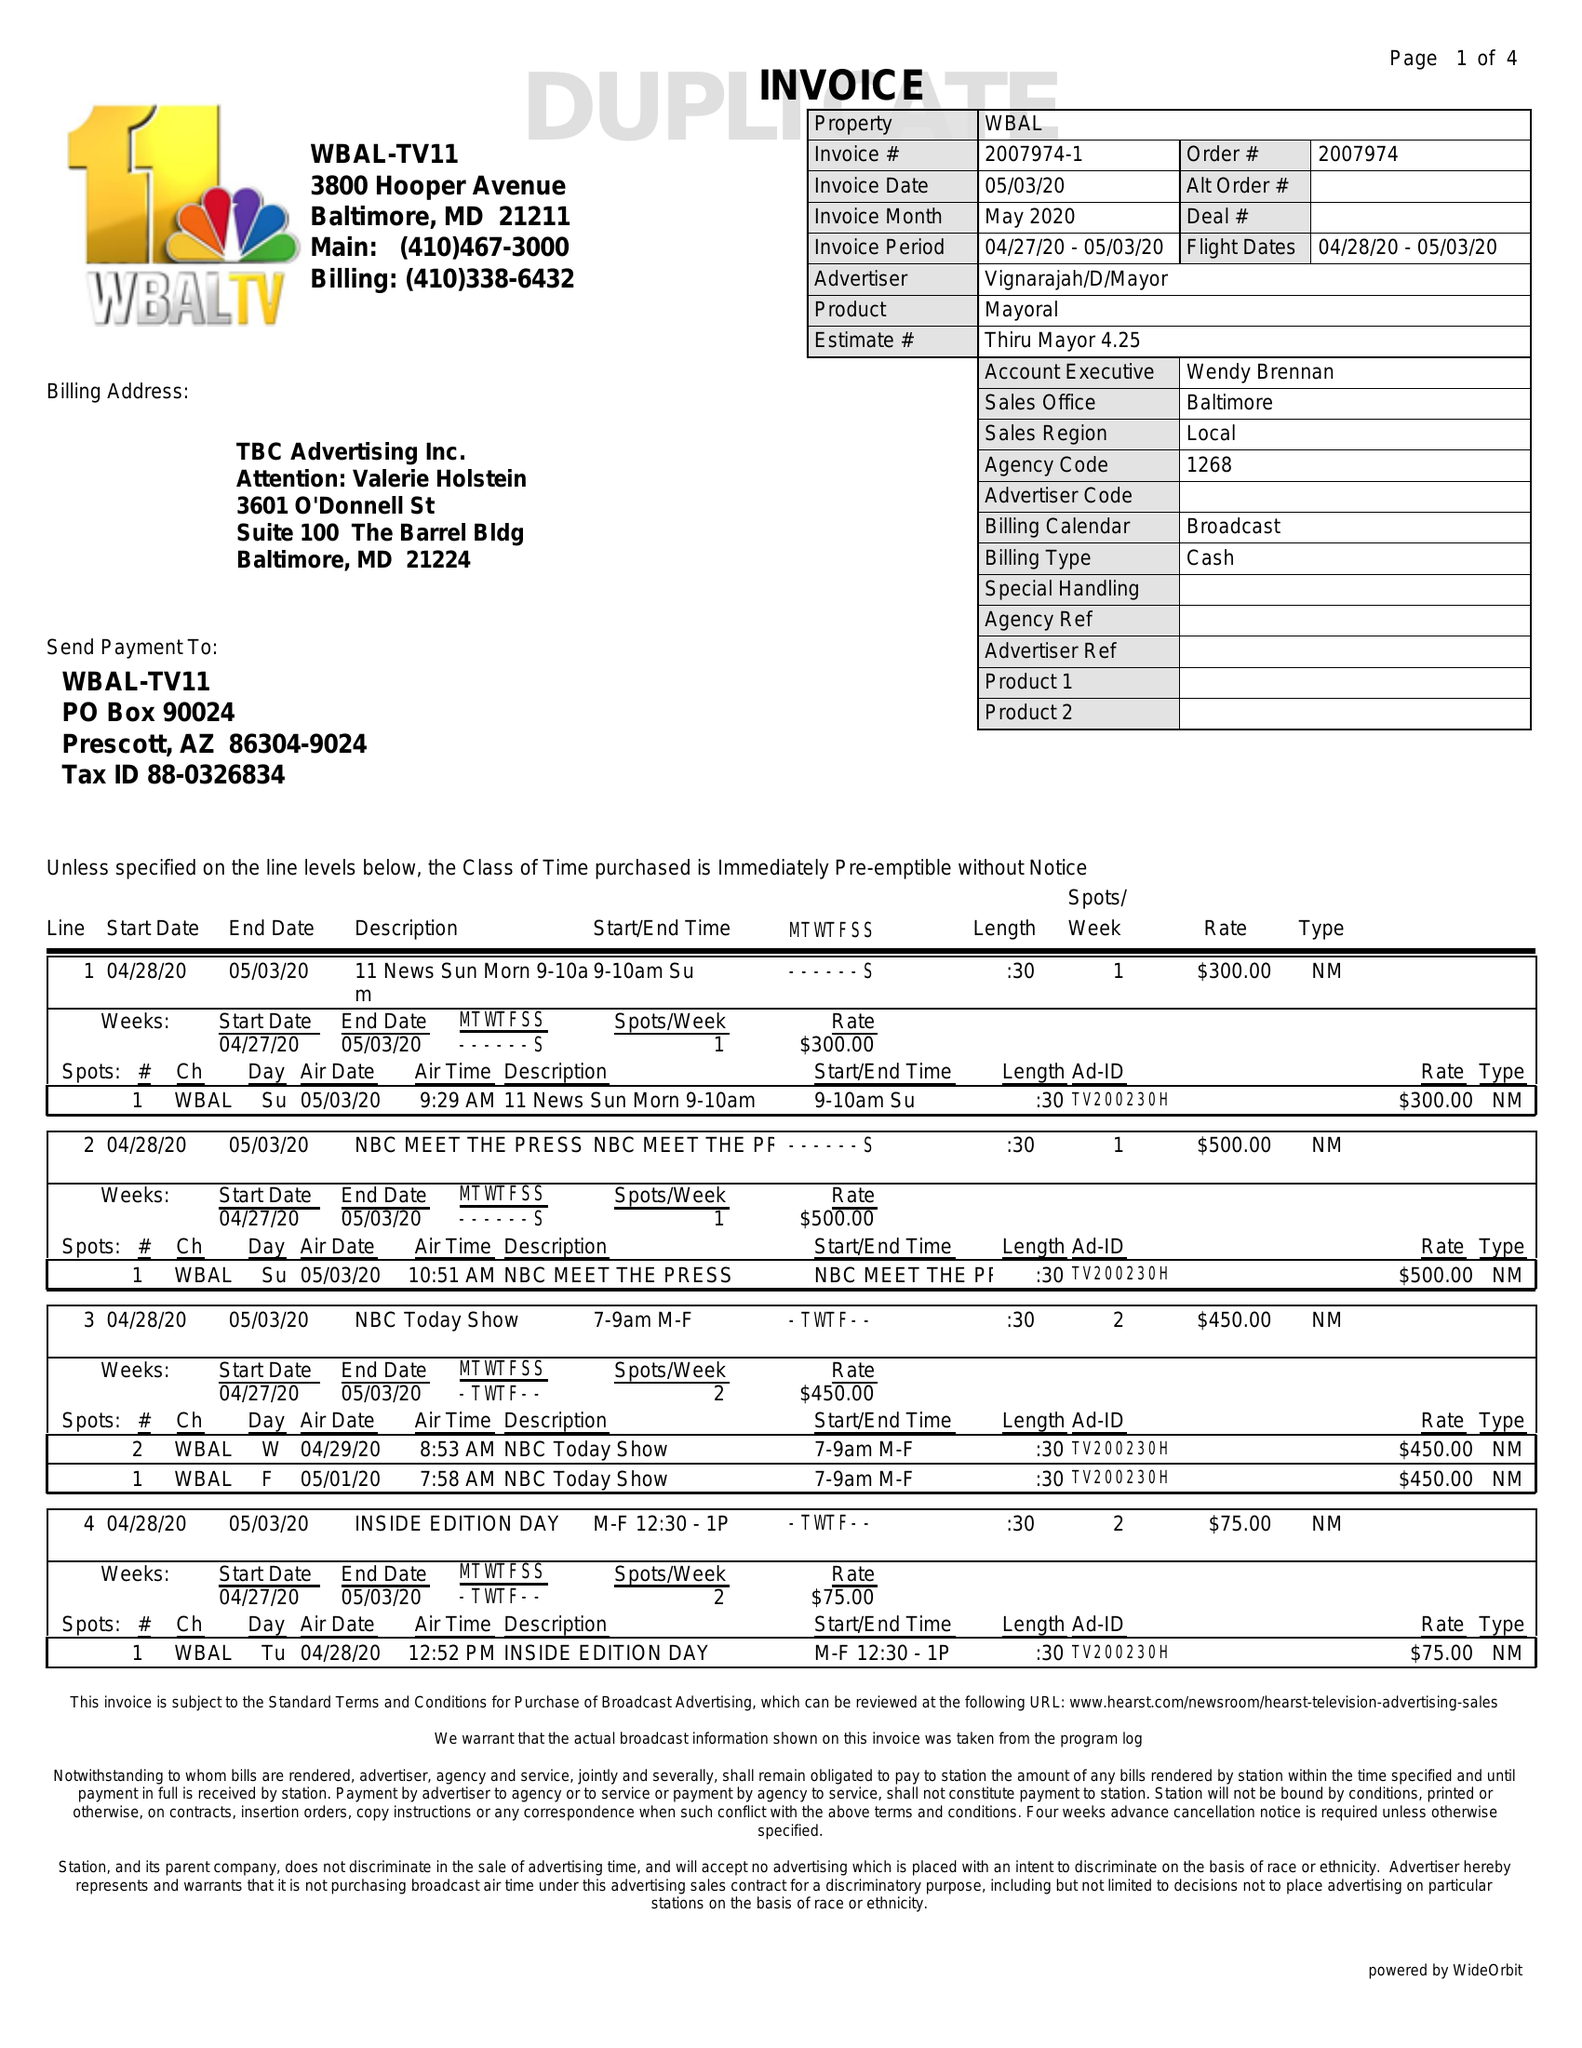What is the value for the contract_num?
Answer the question using a single word or phrase. 2007974 